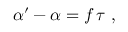<formula> <loc_0><loc_0><loc_500><loc_500>\begin{array} { r } { \alpha ^ { \prime } - \alpha = f \, \tau \ , } \end{array}</formula> 